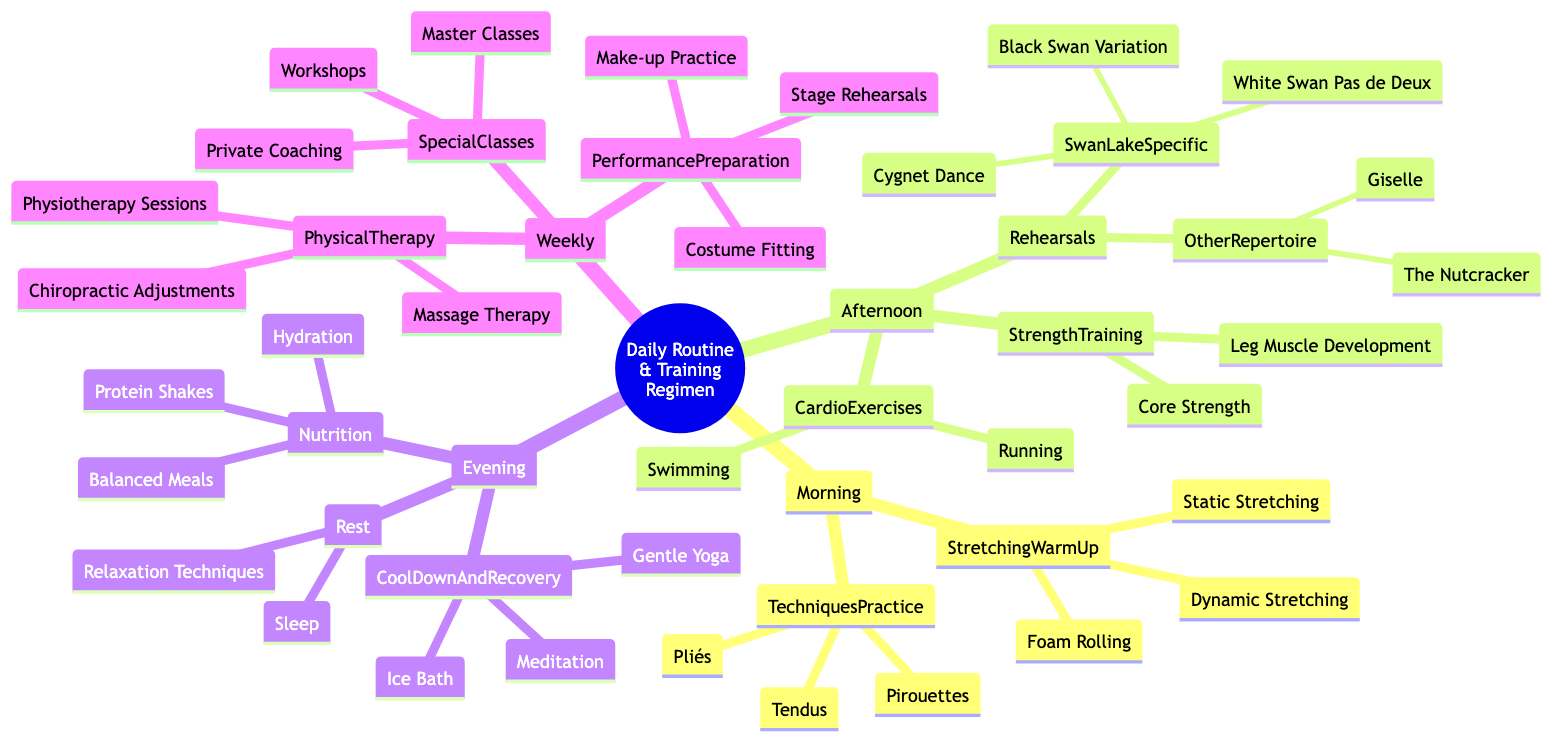What activities are included in the Morning section? The Morning section has two main activities: Stretching Warm-Up and Techniques Practice. These activities further include various specific exercises such as Dynamic Stretching and Pliés.
Answer: Stretching Warm-Up, Techniques Practice How many specific Swan Lake rehearsals are mentioned? Under the Afternoon rehearsals, there are three specific Swan Lake practices listed: White Swan Pas de Deux, Black Swan Variation, and Cygnet Dance. Therefore, counting all of them gives three.
Answer: 3 What kind of strength training is included? The diagram lists two types of strength training: Core Strength and Leg Muscle Development. Thus, by reviewing the Afternoon section, both are part of the strength training regimen.
Answer: Core Strength, Leg Muscle Development Which type of rest activity is included in the Evening? The Evening section contains a Rest category, which specifically includes Sleep and Relaxation Techniques. Overall, both of these relax the body after a day of rigorous activity.
Answer: Sleep, Relaxation Techniques What are the components of Cool Down and Recovery? The Evening section lists Cool Down and Recovery activities that include Gentle Yoga, Meditation, and Ice Bath. These activities emphasize recovery after extensive training.
Answer: Gentle Yoga, Meditation, Ice Bath How many types of Physical Therapy are included in the Weekly routine? The Weekly section incorporates three types of Physical Therapy: Physiotherapy Sessions, Massage Therapy, and Chiropractic Adjustments, totaling three distinct therapies.
Answer: 3 What is the purpose of Special Classes in the Weekly section? Special Classes in the Weekly section serve to provide further education and skill development, with examples given as Master Classes, Workshops, and Private Coaching that enhance techniques and performance.
Answer: Skill development Which cardio exercises are specified in the Afternoon training? The Afternoon training lists two cardio exercises: Running and Swimming, both aimed at boosting cardiovascular fitness and endurance necessary for ballet.
Answer: Running, Swimming What nutritional practices are suggested for the Evening? The Evening section emphasizes Nutrition practices that include Balanced Meals, Protein Shakes, and Hydration, which are essential for recovery and maintaining energy levels.
Answer: Balanced Meals, Protein Shakes, Hydration 